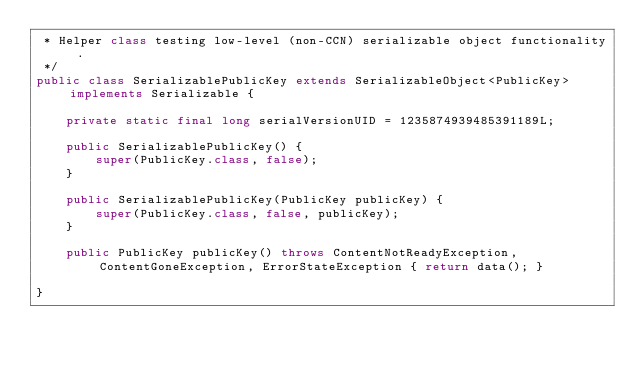Convert code to text. <code><loc_0><loc_0><loc_500><loc_500><_Java_> * Helper class testing low-level (non-CCN) serializable object functionality.
 */
public class SerializablePublicKey extends SerializableObject<PublicKey> implements Serializable {
	
	private static final long serialVersionUID = 1235874939485391189L;

	public SerializablePublicKey() {
		super(PublicKey.class, false);
	}
	
	public SerializablePublicKey(PublicKey publicKey) {
		super(PublicKey.class, false, publicKey);
	}
	
	public PublicKey publicKey() throws ContentNotReadyException, ContentGoneException, ErrorStateException { return data(); }

}
</code> 